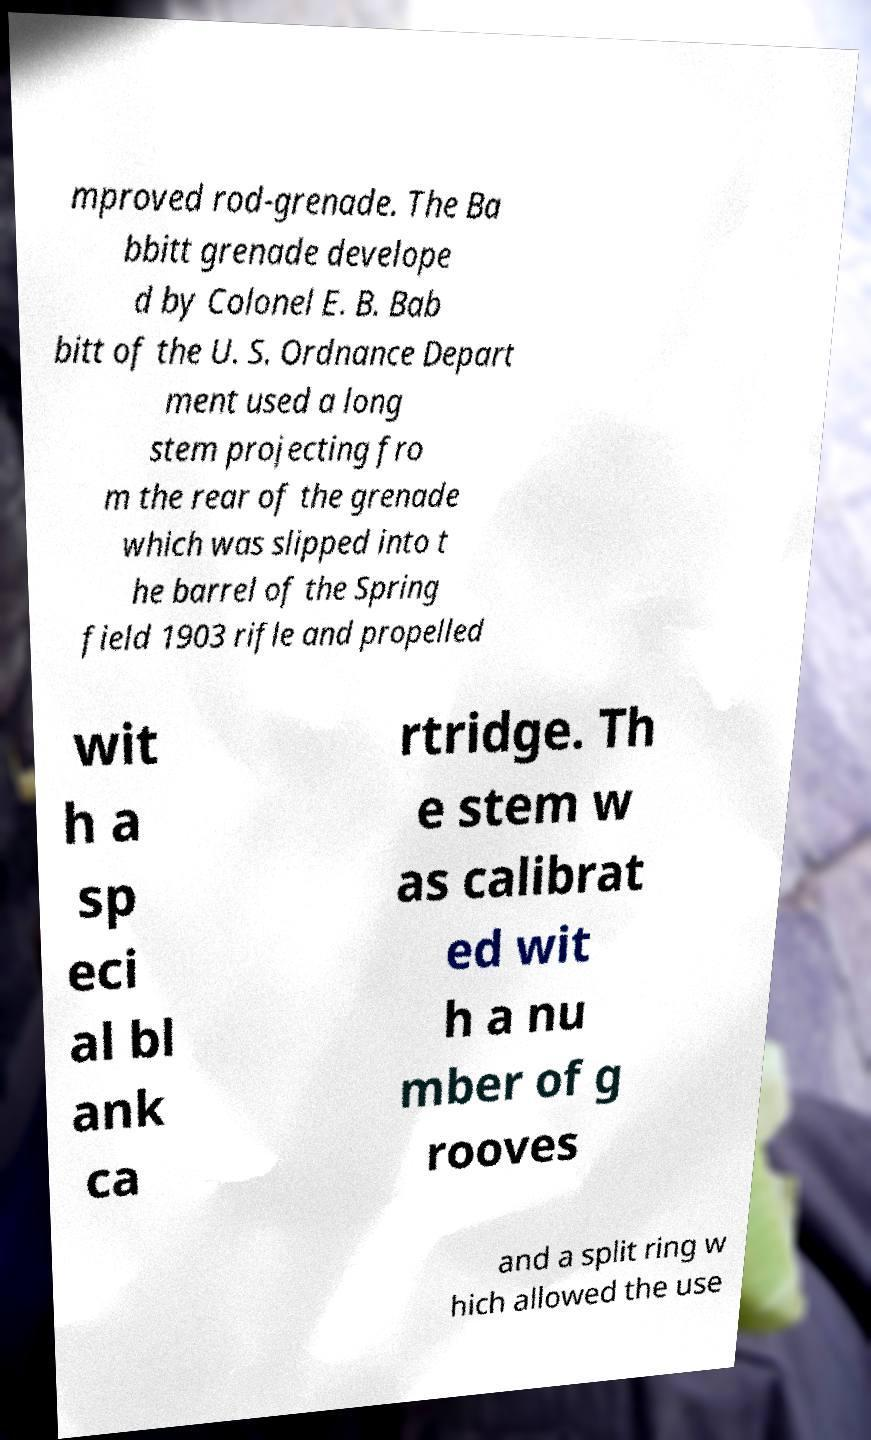What messages or text are displayed in this image? I need them in a readable, typed format. mproved rod-grenade. The Ba bbitt grenade develope d by Colonel E. B. Bab bitt of the U. S. Ordnance Depart ment used a long stem projecting fro m the rear of the grenade which was slipped into t he barrel of the Spring field 1903 rifle and propelled wit h a sp eci al bl ank ca rtridge. Th e stem w as calibrat ed wit h a nu mber of g rooves and a split ring w hich allowed the use 